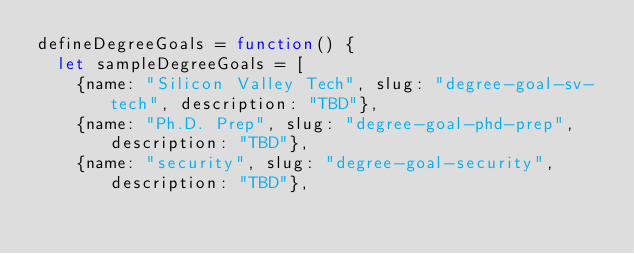<code> <loc_0><loc_0><loc_500><loc_500><_JavaScript_>defineDegreeGoals = function() {
  let sampleDegreeGoals = [
    {name: "Silicon Valley Tech", slug: "degree-goal-sv-tech", description: "TBD"},
    {name: "Ph.D. Prep", slug: "degree-goal-phd-prep", description: "TBD"},
    {name: "security", slug: "degree-goal-security", description: "TBD"},</code> 